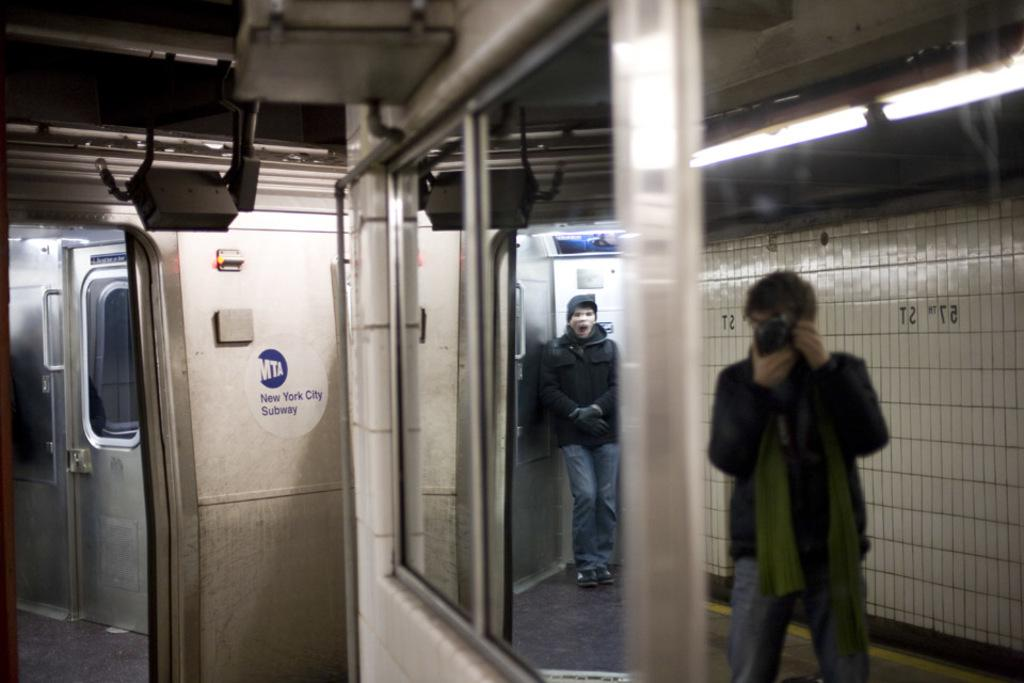<image>
Summarize the visual content of the image. a person taking a photo on the New York subway 